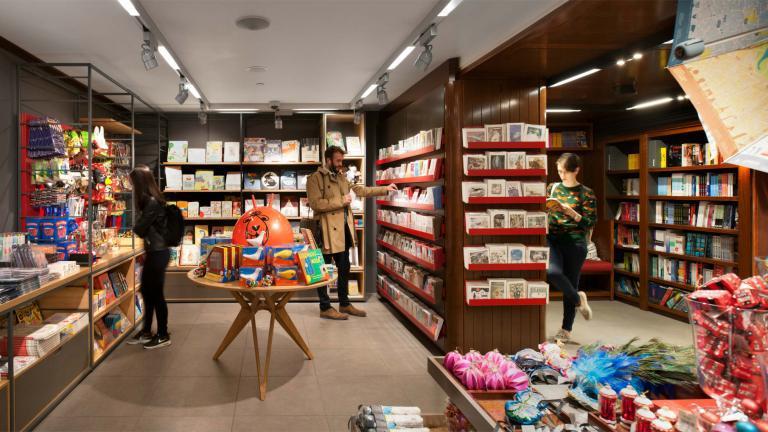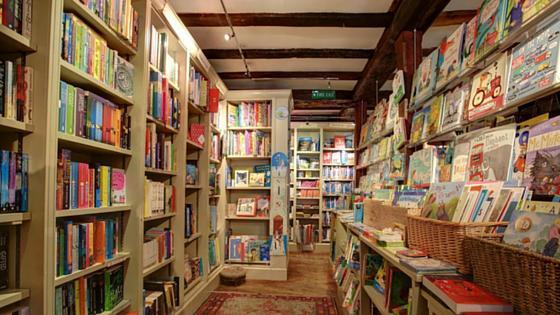The first image is the image on the left, the second image is the image on the right. For the images displayed, is the sentence "No customers can be seen in either bookshop image." factually correct? Answer yes or no. No. 